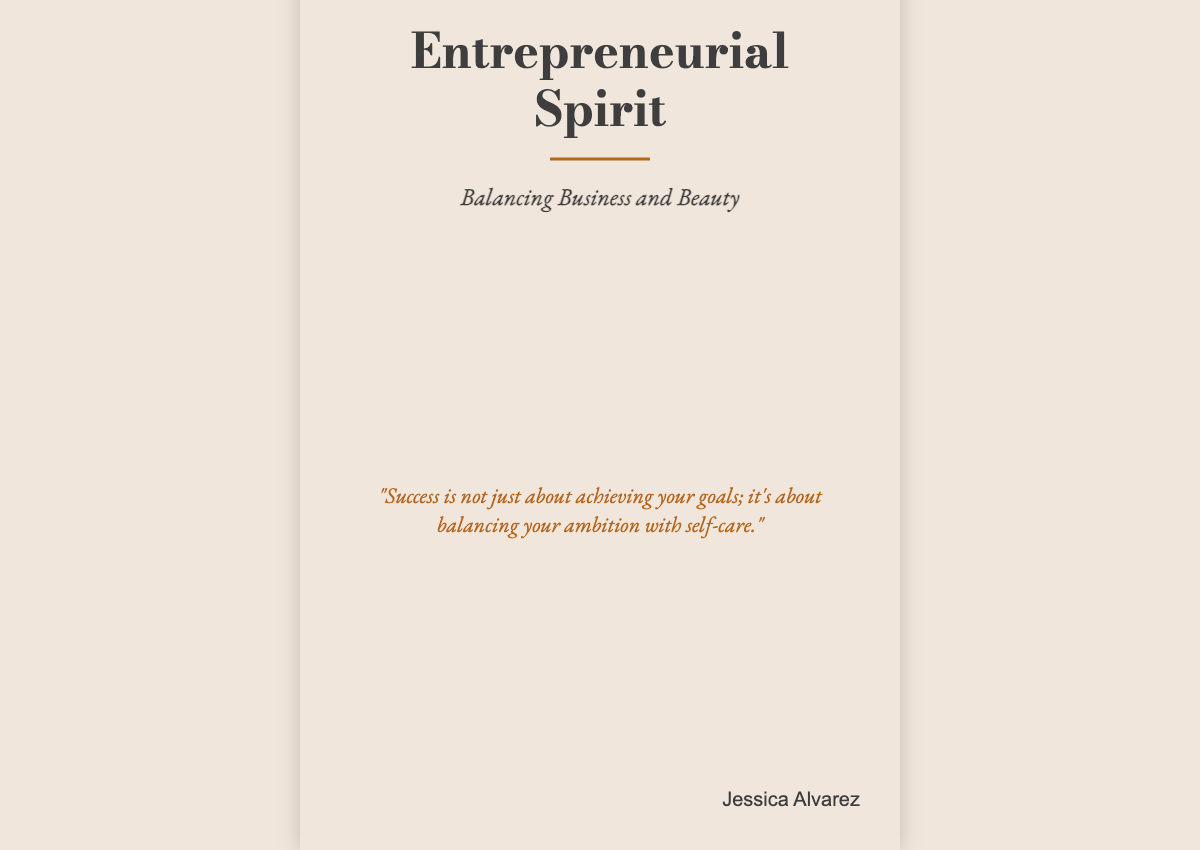What is the title of the book? The title is prominently displayed at the top of the cover in large font.
Answer: Entrepreneurial Spirit Who is the author? The author's name is located at the bottom right of the cover in a smaller font.
Answer: Jessica Alvarez What does the subtitle indicate? The subtitle is given right below the title and provides an idea of the book's focus.
Answer: Balancing Business and Beauty What is the background color of the book cover? The background color is specified in the document styling.
Answer: Soft neutral What is the main focus of the quote on the cover? The quote summarizes a key theme of the book related to success and self-care.
Answer: Balancing ambition with self-care What font is used for the title? The font used for the title is stated in the document.
Answer: Bodoni Moda How many sections are there in the content division of the cover? The content division includes three clearly defined sections.
Answer: Three What visual element enhances the book's message? The cover features imagery that complements the theme of balance in life and work.
Answer: Confident woman juggling What type of book cover is this? The format of the cover is distinct to showcase the book's theme and appeal.
Answer: A book cover 